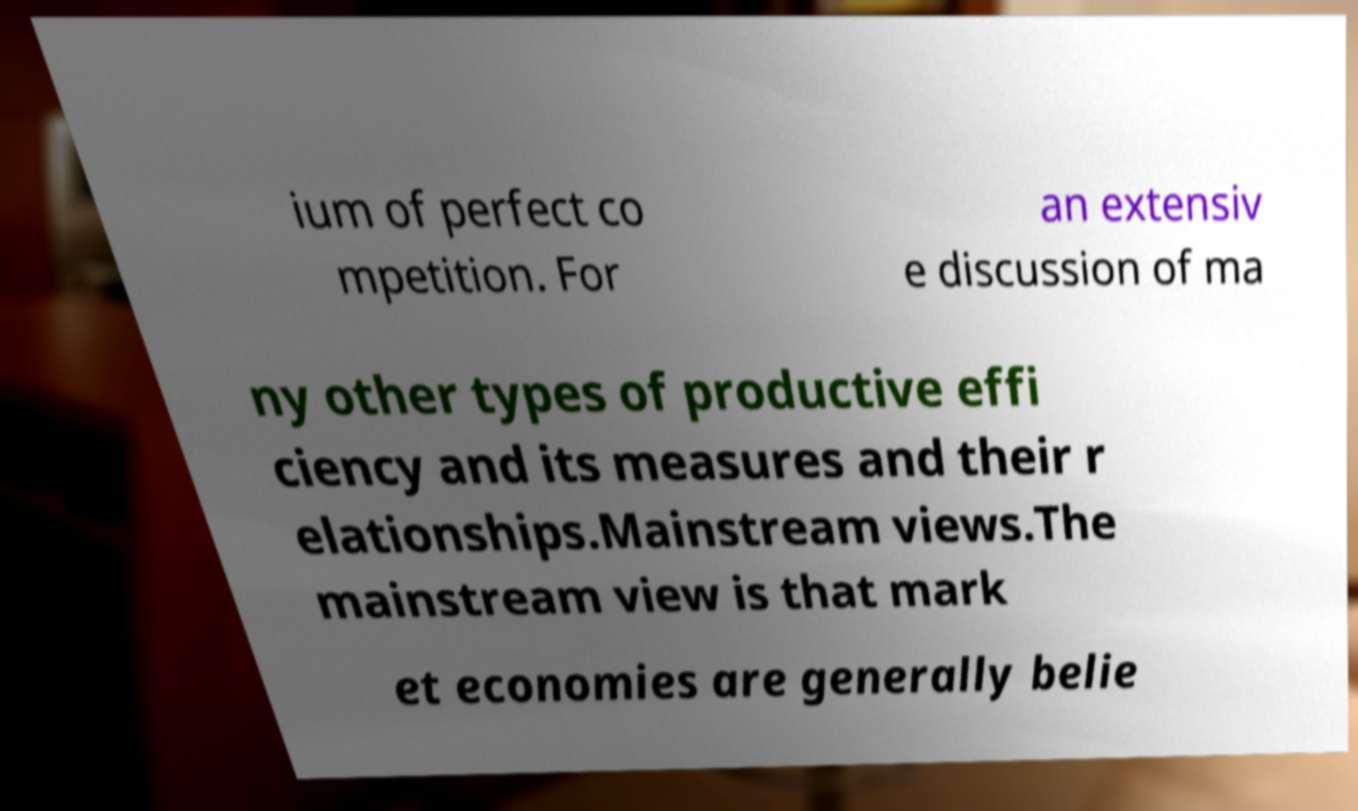There's text embedded in this image that I need extracted. Can you transcribe it verbatim? ium of perfect co mpetition. For an extensiv e discussion of ma ny other types of productive effi ciency and its measures and their r elationships.Mainstream views.The mainstream view is that mark et economies are generally belie 